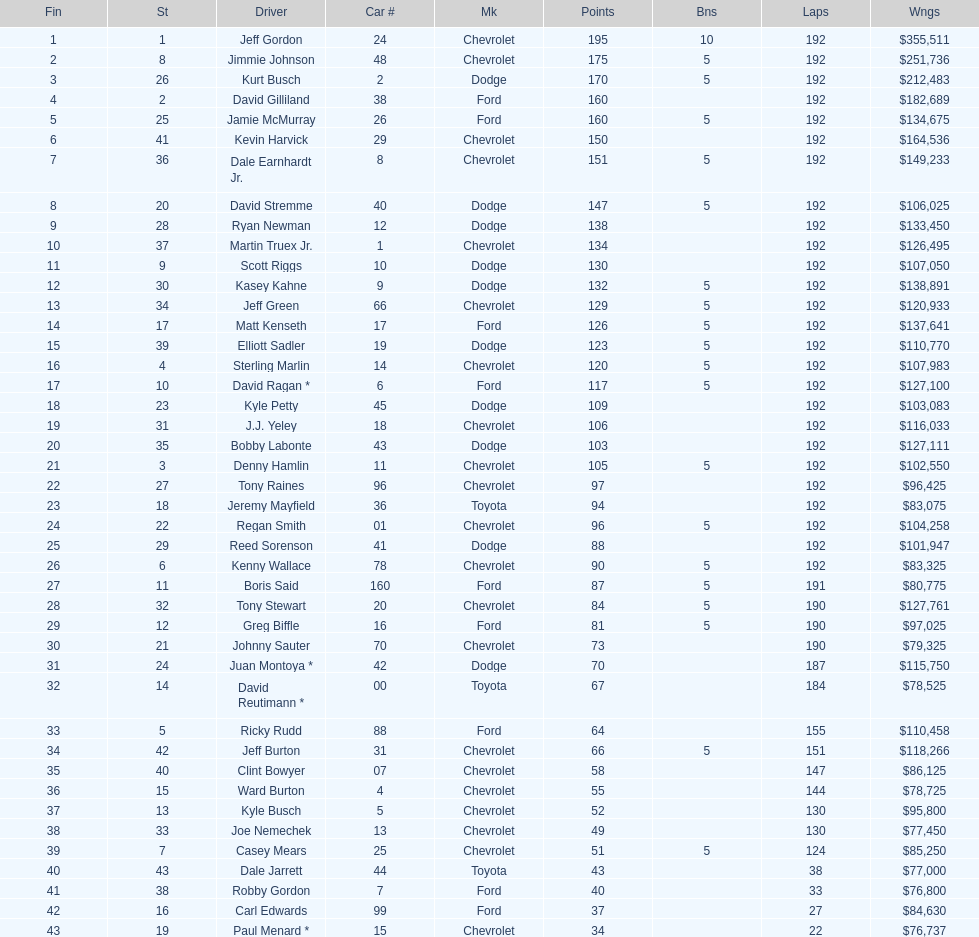What was jimmie johnson's winnings? $251,736. 